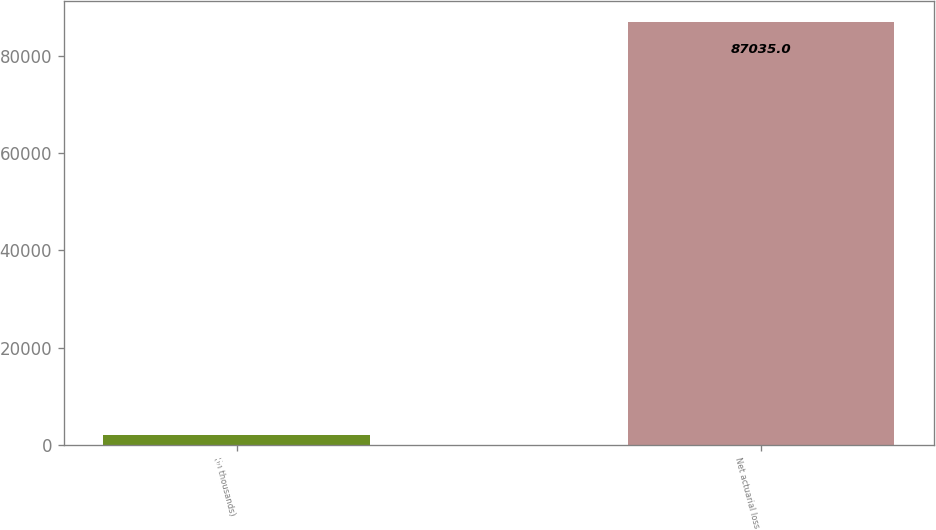<chart> <loc_0><loc_0><loc_500><loc_500><bar_chart><fcel>(in thousands)<fcel>Net actuarial loss<nl><fcel>2011<fcel>87035<nl></chart> 